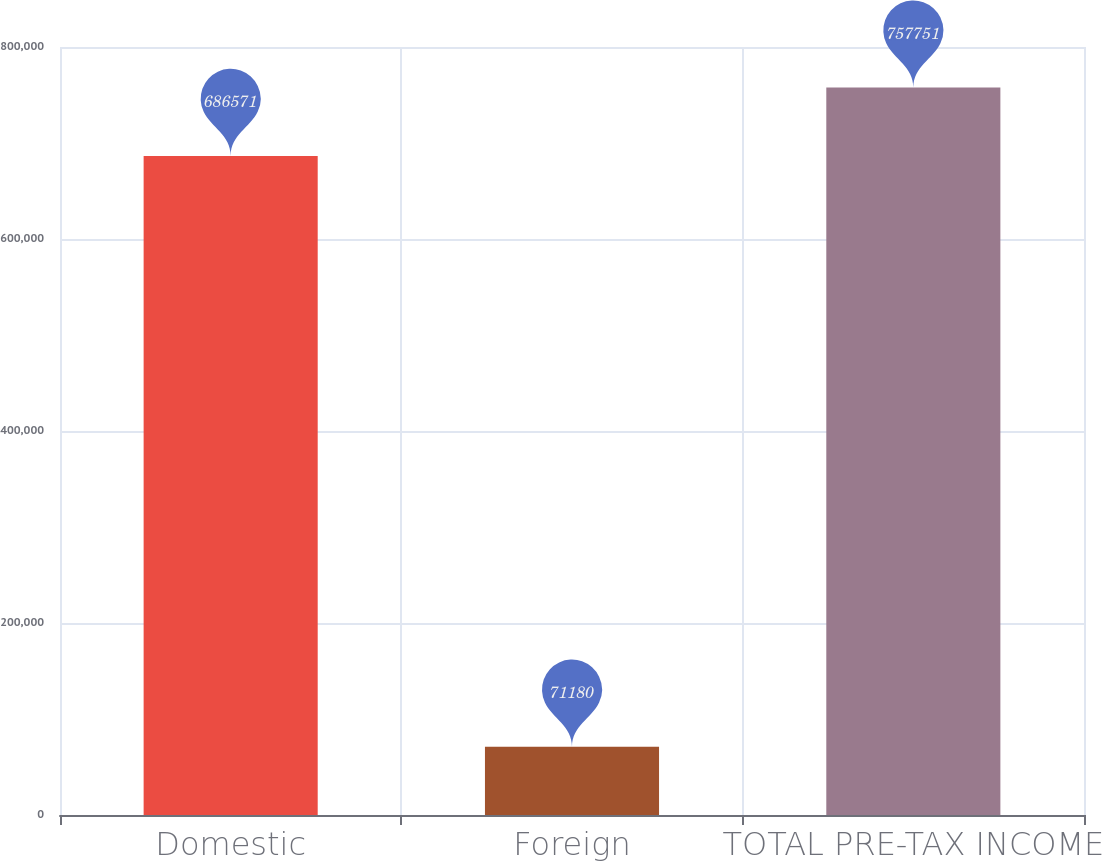Convert chart. <chart><loc_0><loc_0><loc_500><loc_500><bar_chart><fcel>Domestic<fcel>Foreign<fcel>TOTAL PRE-TAX INCOME<nl><fcel>686571<fcel>71180<fcel>757751<nl></chart> 